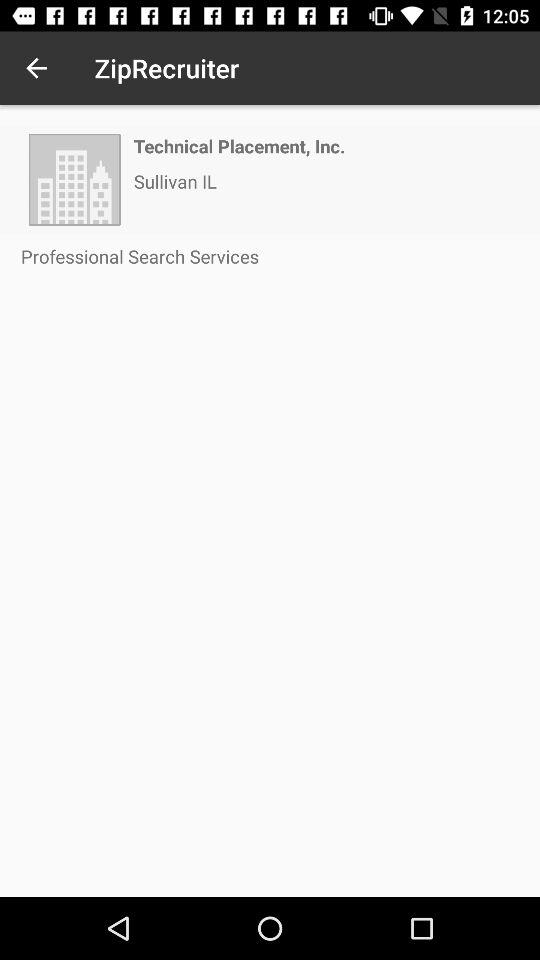What is the name of the application? The name of the application is "ZipRecruiter". 